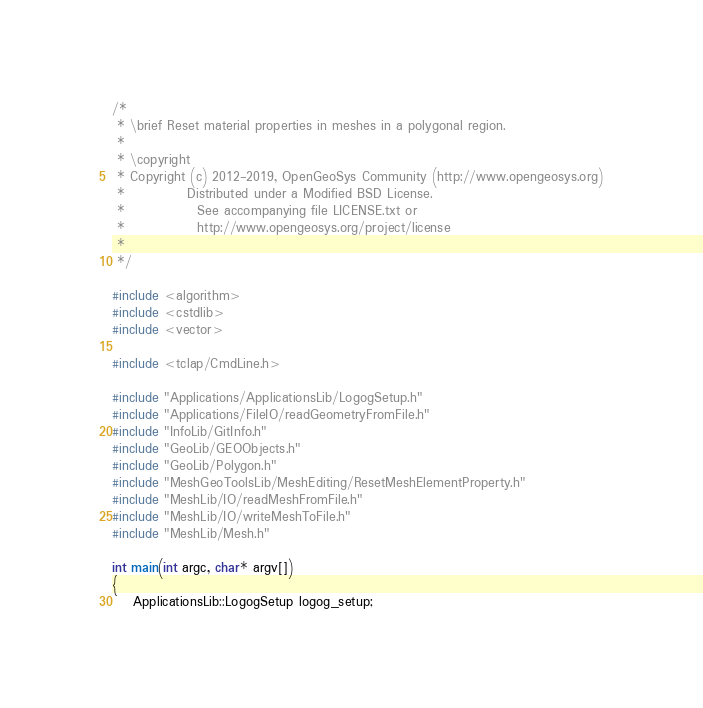<code> <loc_0><loc_0><loc_500><loc_500><_C++_>/*
 * \brief Reset material properties in meshes in a polygonal region.
 *
 * \copyright
 * Copyright (c) 2012-2019, OpenGeoSys Community (http://www.opengeosys.org)
 *            Distributed under a Modified BSD License.
 *              See accompanying file LICENSE.txt or
 *              http://www.opengeosys.org/project/license
 *
 */

#include <algorithm>
#include <cstdlib>
#include <vector>

#include <tclap/CmdLine.h>

#include "Applications/ApplicationsLib/LogogSetup.h"
#include "Applications/FileIO/readGeometryFromFile.h"
#include "InfoLib/GitInfo.h"
#include "GeoLib/GEOObjects.h"
#include "GeoLib/Polygon.h"
#include "MeshGeoToolsLib/MeshEditing/ResetMeshElementProperty.h"
#include "MeshLib/IO/readMeshFromFile.h"
#include "MeshLib/IO/writeMeshToFile.h"
#include "MeshLib/Mesh.h"

int main(int argc, char* argv[])
{
    ApplicationsLib::LogogSetup logog_setup;
</code> 